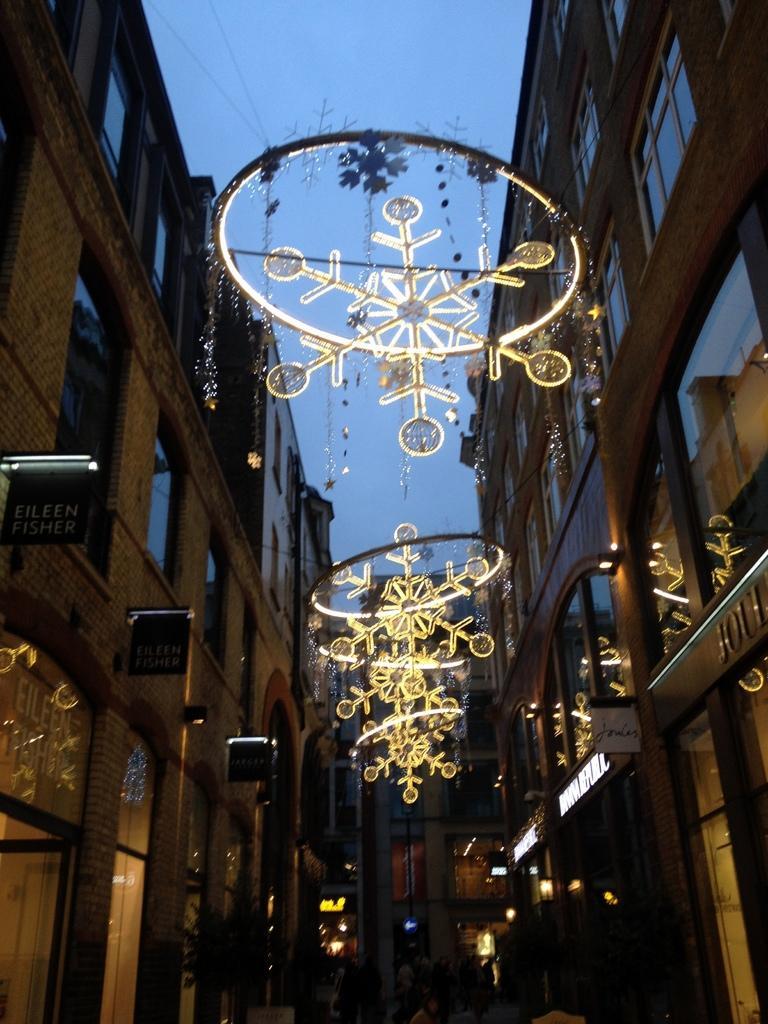Describe this image in one or two sentences. Here we can see decorative lights in the middle and on the left and right side we can see buildings,windows,small boards on the wall,lights,hoardings and other objects. In the background we can see the sky. 